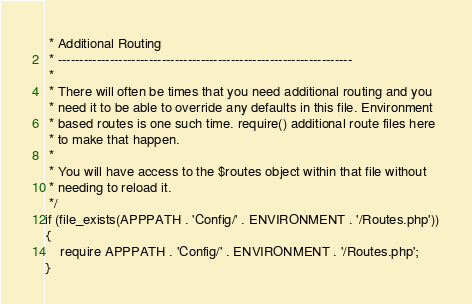Convert code to text. <code><loc_0><loc_0><loc_500><loc_500><_PHP_> * Additional Routing
 * --------------------------------------------------------------------
 *
 * There will often be times that you need additional routing and you
 * need it to be able to override any defaults in this file. Environment
 * based routes is one such time. require() additional route files here
 * to make that happen.
 *
 * You will have access to the $routes object within that file without
 * needing to reload it.
 */
if (file_exists(APPPATH . 'Config/' . ENVIRONMENT . '/Routes.php'))
{
	require APPPATH . 'Config/' . ENVIRONMENT . '/Routes.php';
}
</code> 